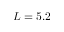Convert formula to latex. <formula><loc_0><loc_0><loc_500><loc_500>L = 5 . 2</formula> 